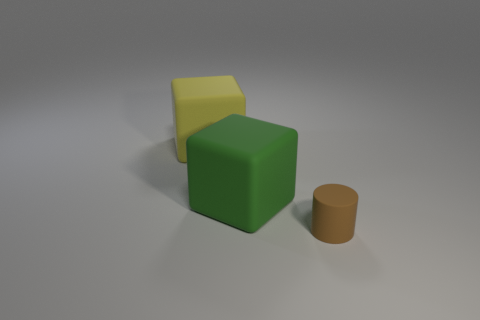How many large green things are in front of the yellow block?
Provide a succinct answer. 1. What is the color of the other matte object that is the same shape as the large yellow matte thing?
Ensure brevity in your answer.  Green. How many rubber objects are green cubes or big purple things?
Give a very brief answer. 1. Are there any big matte blocks to the right of the big matte cube that is left of the block in front of the large yellow rubber thing?
Your answer should be very brief. Yes. What is the color of the cylinder?
Offer a very short reply. Brown. Do the big matte thing on the right side of the big yellow block and the brown rubber thing have the same shape?
Your answer should be compact. No. What number of things are either green objects or things behind the large green cube?
Provide a succinct answer. 2. Do the big thing on the left side of the large green cube and the green object have the same material?
Provide a succinct answer. Yes. Is there any other thing that is the same size as the yellow cube?
Your answer should be compact. Yes. What is the material of the block right of the thing that is behind the green object?
Provide a succinct answer. Rubber. 